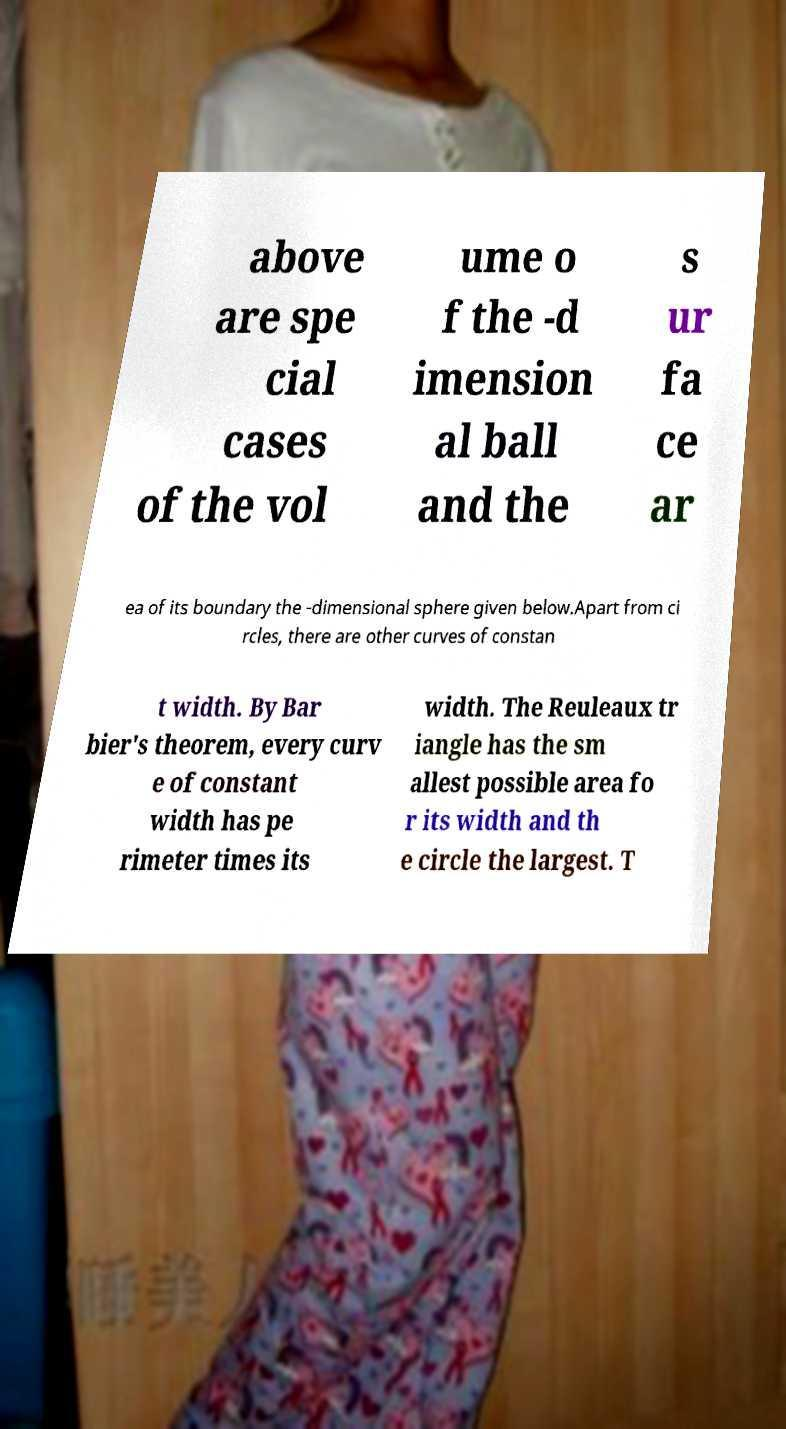Could you assist in decoding the text presented in this image and type it out clearly? above are spe cial cases of the vol ume o f the -d imension al ball and the s ur fa ce ar ea of its boundary the -dimensional sphere given below.Apart from ci rcles, there are other curves of constan t width. By Bar bier's theorem, every curv e of constant width has pe rimeter times its width. The Reuleaux tr iangle has the sm allest possible area fo r its width and th e circle the largest. T 